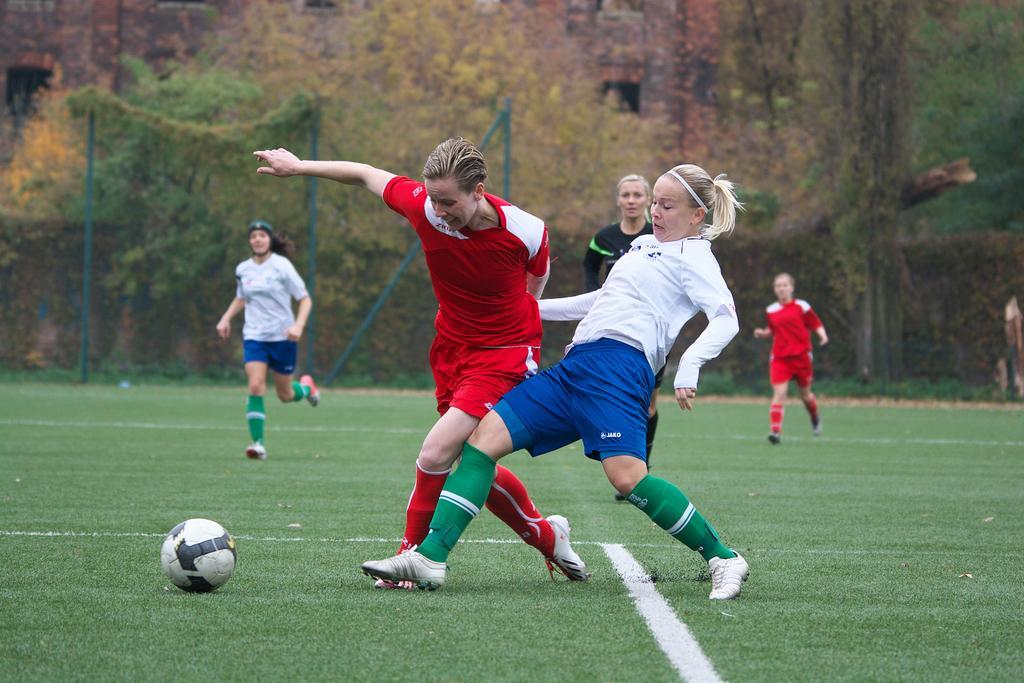Could you give a brief overview of what you see in this image? In this picture we can see a ball and a group of people running on the ground, fence and in the background we can see trees. 